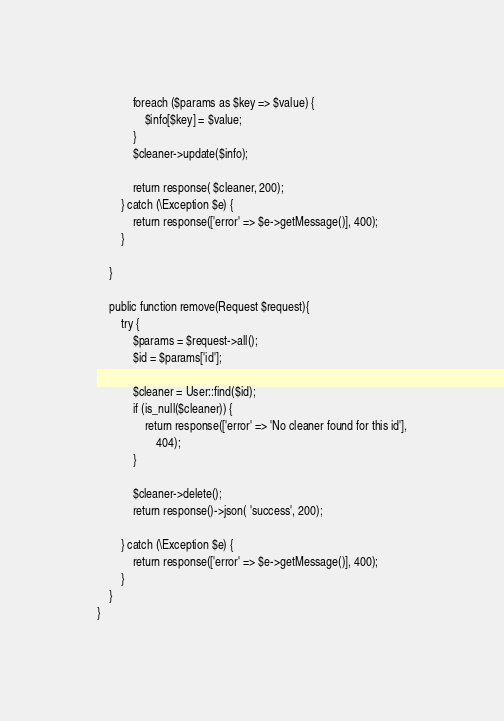<code> <loc_0><loc_0><loc_500><loc_500><_PHP_>            foreach ($params as $key => $value) {
                $info[$key] = $value;
            }
            $cleaner->update($info);

            return response( $cleaner, 200);
        } catch (\Exception $e) {
            return response(['error' => $e->getMessage()], 400);
        }

    }

    public function remove(Request $request){
        try {
            $params = $request->all();
            $id = $params['id'];

            $cleaner = User::find($id);
            if (is_null($cleaner)) {
                return response(['error' => 'No cleaner found for this id'],
                    404);
            }

            $cleaner->delete();
            return response()->json( 'success', 200);

        } catch (\Exception $e) {
            return response(['error' => $e->getMessage()], 400);
        }
    }
}
</code> 